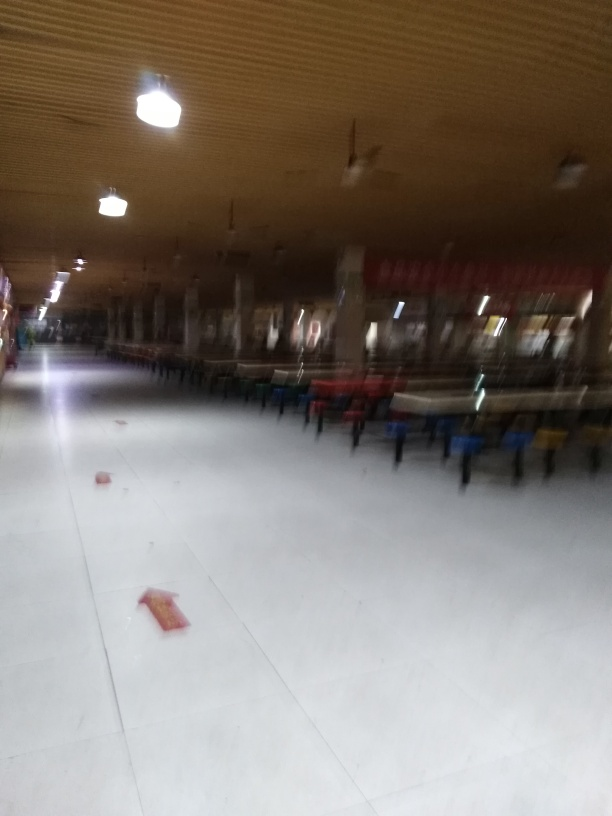What kind of place is shown in the image? The image depicts an indoor space that resembles a cafeteria or dining hall, characterized by rows of tables and chairs. The ceiling fans and the large space suggest it's designed to accommodate many people at once, possibly in an institutional, educational, or corporate environment. 